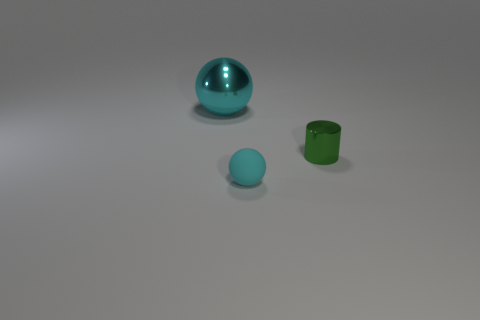There is a thing that is both on the left side of the green metal cylinder and behind the tiny matte ball; how big is it?
Ensure brevity in your answer.  Large. Is the number of tiny cyan things that are on the left side of the small metal cylinder less than the number of tiny green objects?
Offer a terse response. No. Is the material of the small green cylinder the same as the tiny cyan object?
Offer a very short reply. No. How many things are either yellow rubber cubes or big cyan shiny objects?
Give a very brief answer. 1. What number of cyan spheres are made of the same material as the cylinder?
Provide a short and direct response. 1. What is the size of the other cyan object that is the same shape as the cyan rubber thing?
Make the answer very short. Large. There is a cylinder; are there any tiny cyan things to the right of it?
Provide a short and direct response. No. What material is the tiny green cylinder?
Your answer should be very brief. Metal. Do the small thing left of the green metallic cylinder and the metal sphere have the same color?
Your answer should be compact. Yes. Are there any other things that have the same shape as the green shiny object?
Offer a very short reply. No. 